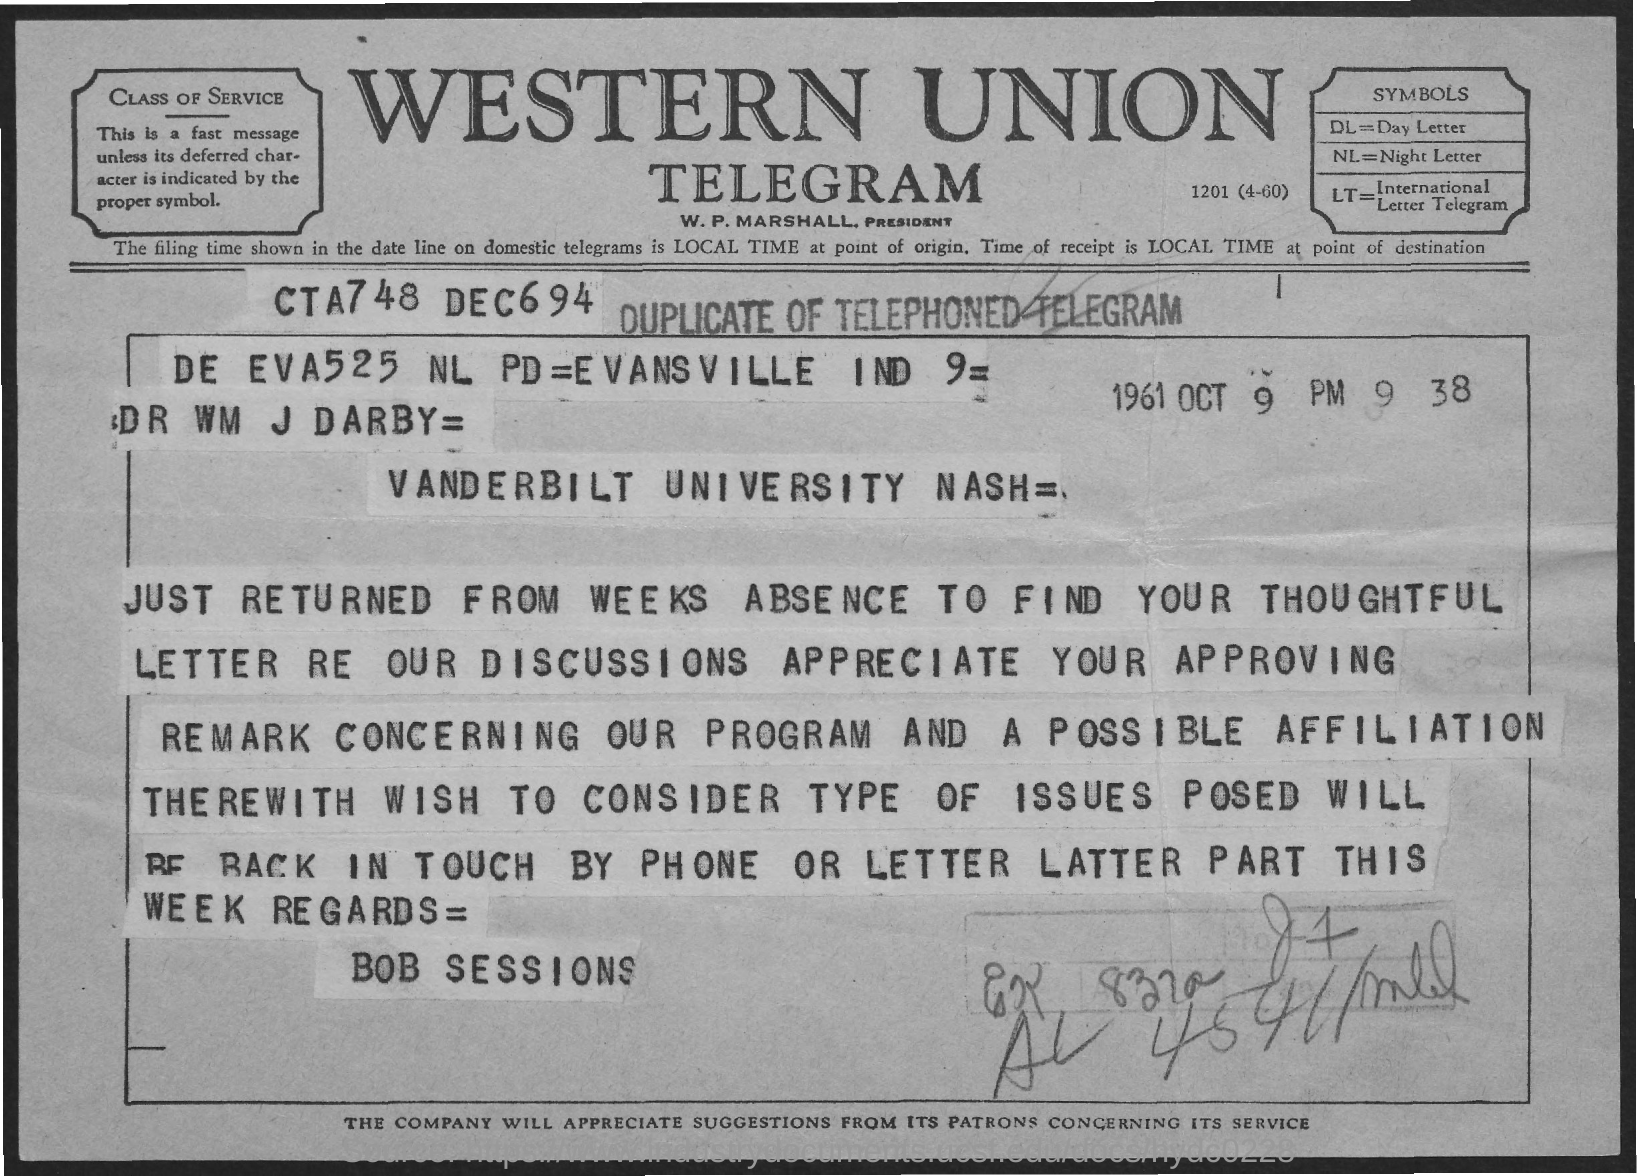To Whom is this Telegram addressed to?
Give a very brief answer. Dr Wm J Darby. Who is this Telegram from?
Your answer should be very brief. Bob Sessions. 